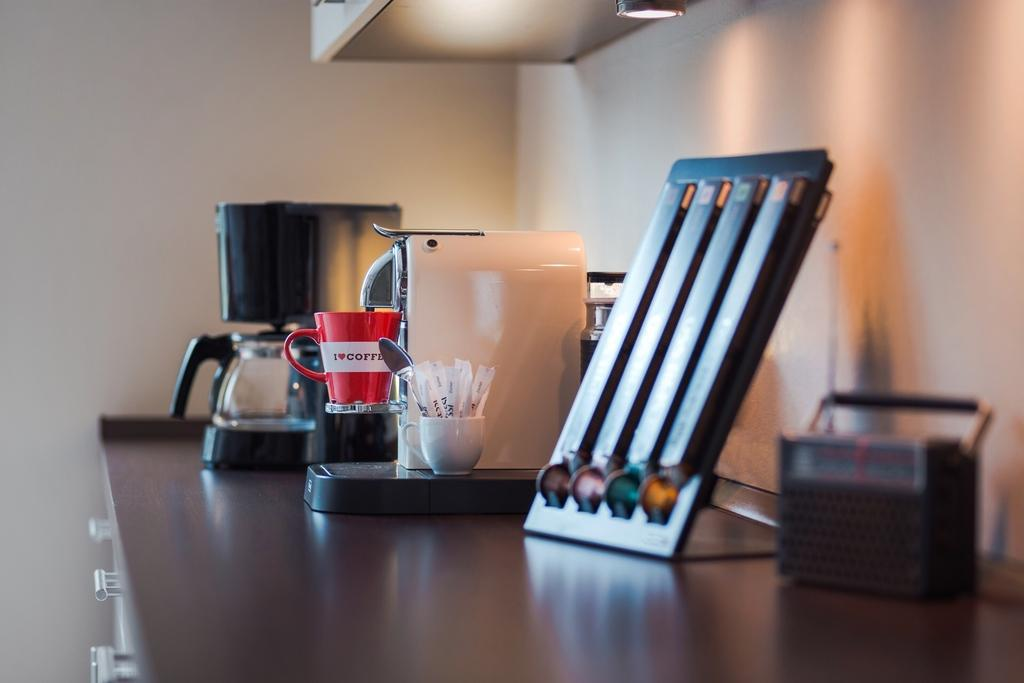What objects are on the table in the image? There are cups on a table in the image. Can you describe the contents of one of the cups? There is a cup with objects in the image. What utensil is present in the image? There is a spoon in the image. What type of cave can be seen in the background of the image? There is no cave present in the image; it features cups on a table and a spoon. What year is depicted in the image? The image does not depict a specific year; it is a still image of cups on a table and a spoon. 